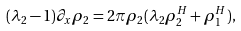<formula> <loc_0><loc_0><loc_500><loc_500>( { \lambda } _ { 2 } - 1 ) \partial _ { x } { \rho } _ { 2 } = 2 \pi { \rho } _ { 2 } ( { \lambda } _ { 2 } { \rho } _ { 2 } ^ { H } + { \rho } _ { 1 } ^ { H } ) ,</formula> 